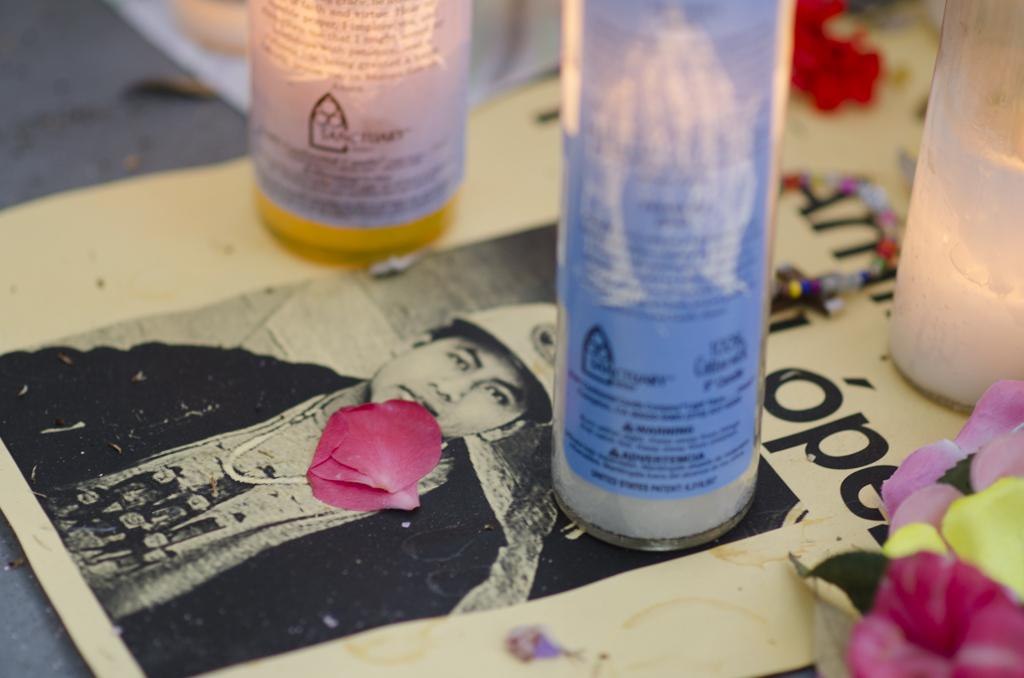What is located in the foreground of the image? There is a poster in the foreground of the image. What can be seen on the surface where the poster is placed? There are bottle-like objects, flower petals, and a chain on the surface with the poster. What word is causing the chain to swing in the image? There is no chain swinging in the image, and no word is mentioned that could cause it to swing. 